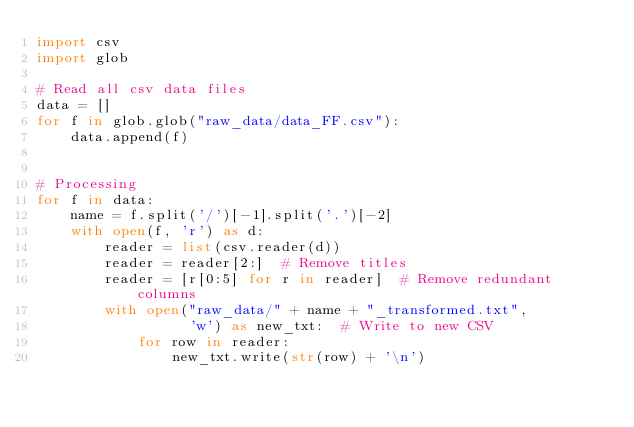Convert code to text. <code><loc_0><loc_0><loc_500><loc_500><_Python_>import csv
import glob

# Read all csv data files
data = []
for f in glob.glob("raw_data/data_FF.csv"):
    data.append(f)


# Processing
for f in data:
    name = f.split('/')[-1].split('.')[-2]
    with open(f, 'r') as d:
        reader = list(csv.reader(d))
        reader = reader[2:]  # Remove titles
        reader = [r[0:5] for r in reader]  # Remove redundant columns
        with open("raw_data/" + name + "_transformed.txt",
                  'w') as new_txt:  # Write to new CSV
            for row in reader:
                new_txt.write(str(row) + '\n')

</code> 